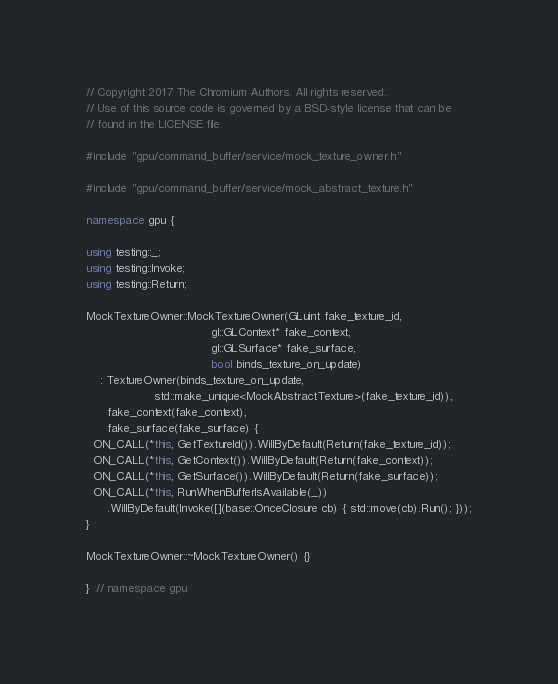Convert code to text. <code><loc_0><loc_0><loc_500><loc_500><_C++_>// Copyright 2017 The Chromium Authors. All rights reserved.
// Use of this source code is governed by a BSD-style license that can be
// found in the LICENSE file.

#include "gpu/command_buffer/service/mock_texture_owner.h"

#include "gpu/command_buffer/service/mock_abstract_texture.h"

namespace gpu {

using testing::_;
using testing::Invoke;
using testing::Return;

MockTextureOwner::MockTextureOwner(GLuint fake_texture_id,
                                   gl::GLContext* fake_context,
                                   gl::GLSurface* fake_surface,
                                   bool binds_texture_on_update)
    : TextureOwner(binds_texture_on_update,
                   std::make_unique<MockAbstractTexture>(fake_texture_id)),
      fake_context(fake_context),
      fake_surface(fake_surface) {
  ON_CALL(*this, GetTextureId()).WillByDefault(Return(fake_texture_id));
  ON_CALL(*this, GetContext()).WillByDefault(Return(fake_context));
  ON_CALL(*this, GetSurface()).WillByDefault(Return(fake_surface));
  ON_CALL(*this, RunWhenBufferIsAvailable(_))
      .WillByDefault(Invoke([](base::OnceClosure cb) { std::move(cb).Run(); }));
}

MockTextureOwner::~MockTextureOwner() {}

}  // namespace gpu
</code> 